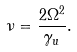Convert formula to latex. <formula><loc_0><loc_0><loc_500><loc_500>\nu = \frac { 2 \Omega ^ { 2 } } { \gamma _ { u } } .</formula> 